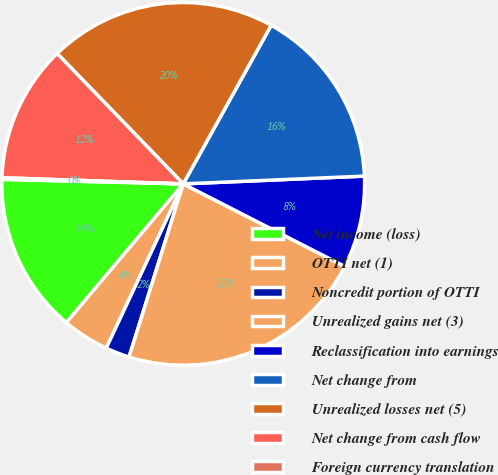Convert chart. <chart><loc_0><loc_0><loc_500><loc_500><pie_chart><fcel>Net income (loss)<fcel>OTTI net (1)<fcel>Noncredit portion of OTTI<fcel>Unrealized gains net (3)<fcel>Reclassification into earnings<fcel>Net change from<fcel>Unrealized losses net (5)<fcel>Net change from cash flow<fcel>Foreign currency translation<nl><fcel>14.25%<fcel>4.17%<fcel>2.15%<fcel>22.31%<fcel>8.2%<fcel>16.26%<fcel>20.29%<fcel>12.23%<fcel>0.14%<nl></chart> 